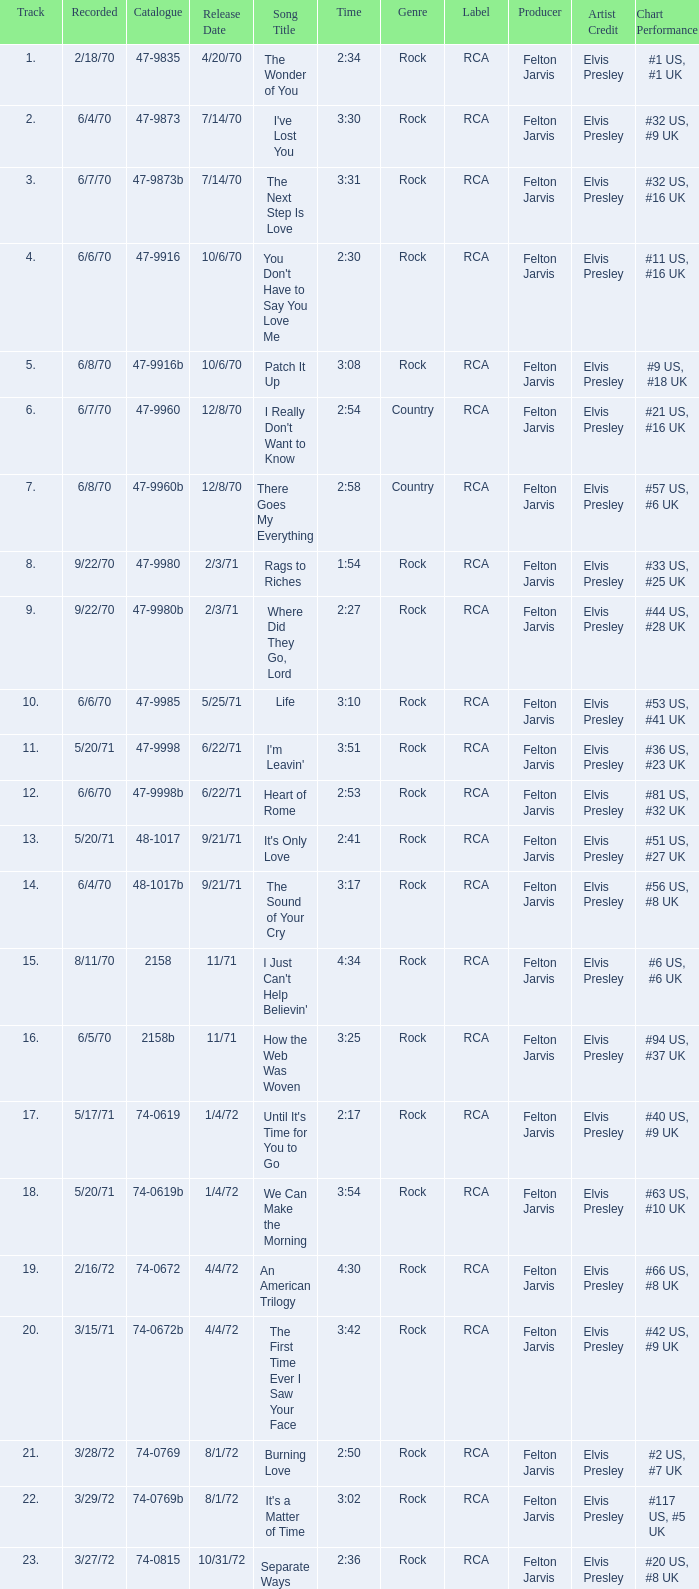What is the catalogue number for the song that is 3:17 and was released 9/21/71? 48-1017b. 